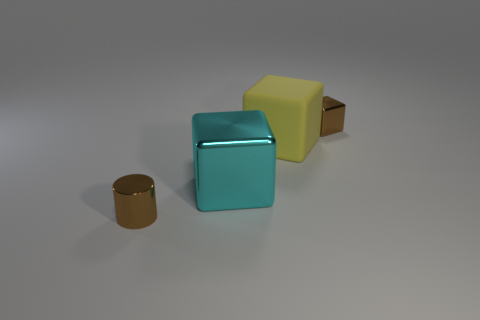Add 2 rubber cubes. How many objects exist? 6 Subtract all cylinders. How many objects are left? 3 Add 4 brown metal blocks. How many brown metal blocks are left? 5 Add 1 red objects. How many red objects exist? 1 Subtract 0 blue cylinders. How many objects are left? 4 Subtract all gray metal balls. Subtract all tiny brown objects. How many objects are left? 2 